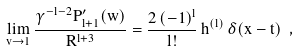Convert formula to latex. <formula><loc_0><loc_0><loc_500><loc_500>\lim _ { v \rightarrow 1 } \frac { \gamma ^ { - l - 2 } P ^ { \prime } _ { l + 1 } ( w ) } { R ^ { l + 3 } } = \frac { 2 \, ( - 1 ) ^ { l } } { l ! } \, h ^ { ( l ) } \, \delta ( x - t ) \ ,</formula> 